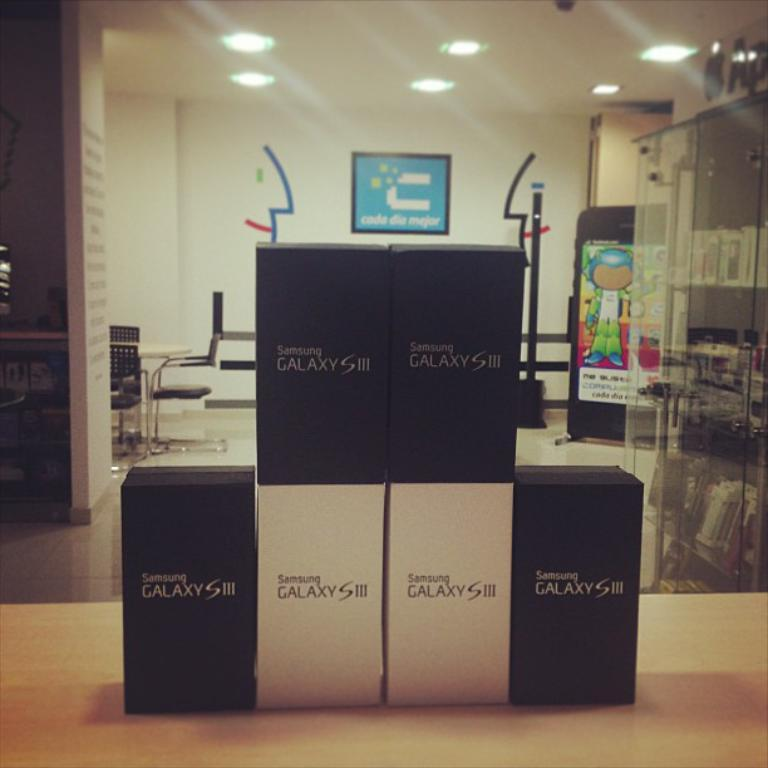<image>
Summarize the visual content of the image. a box that says Samsung Galaxy on it 